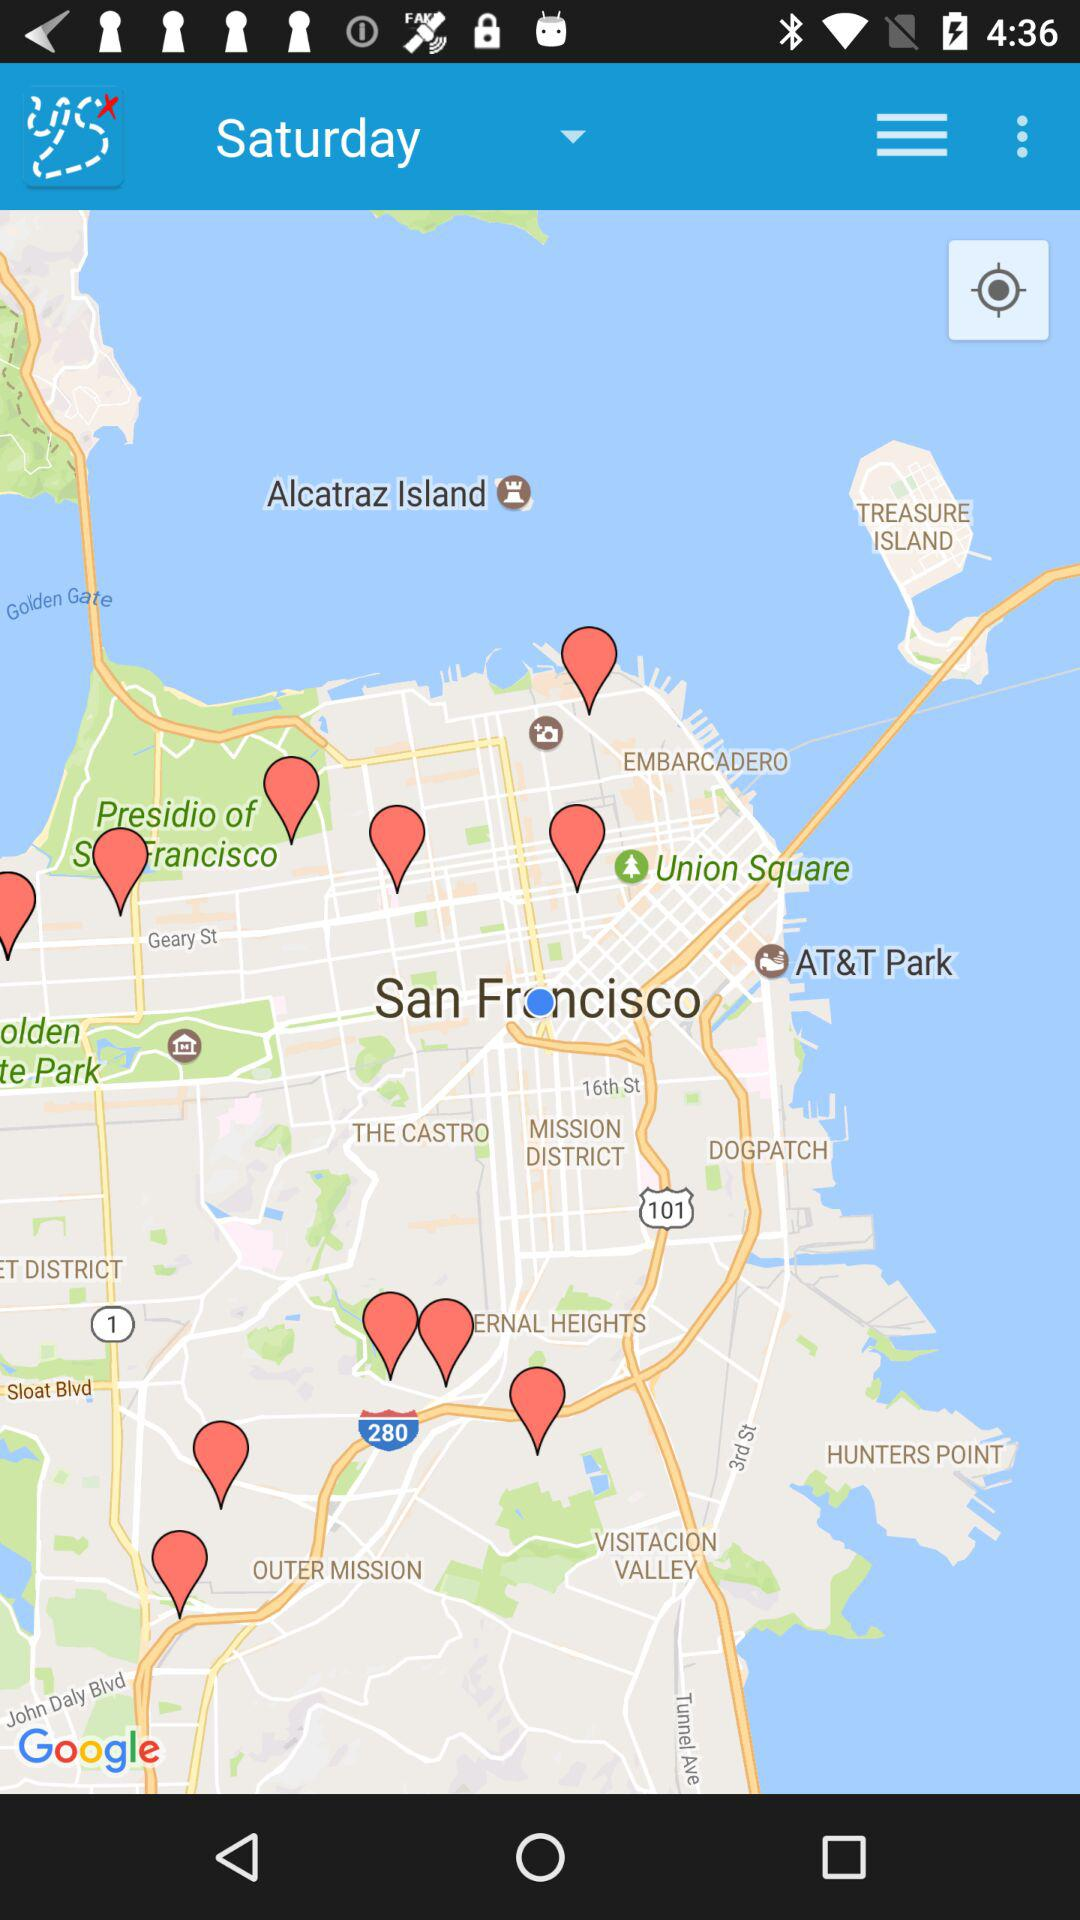What day has been shown? The day is Saturday. 